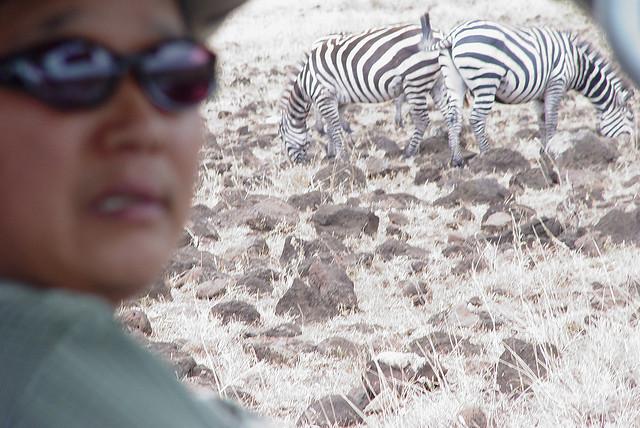How many zebras are here?
Quick response, please. 2. What color is the man's shirt?
Keep it brief. Green. What color are the men's sunglasses?
Quick response, please. Black. 